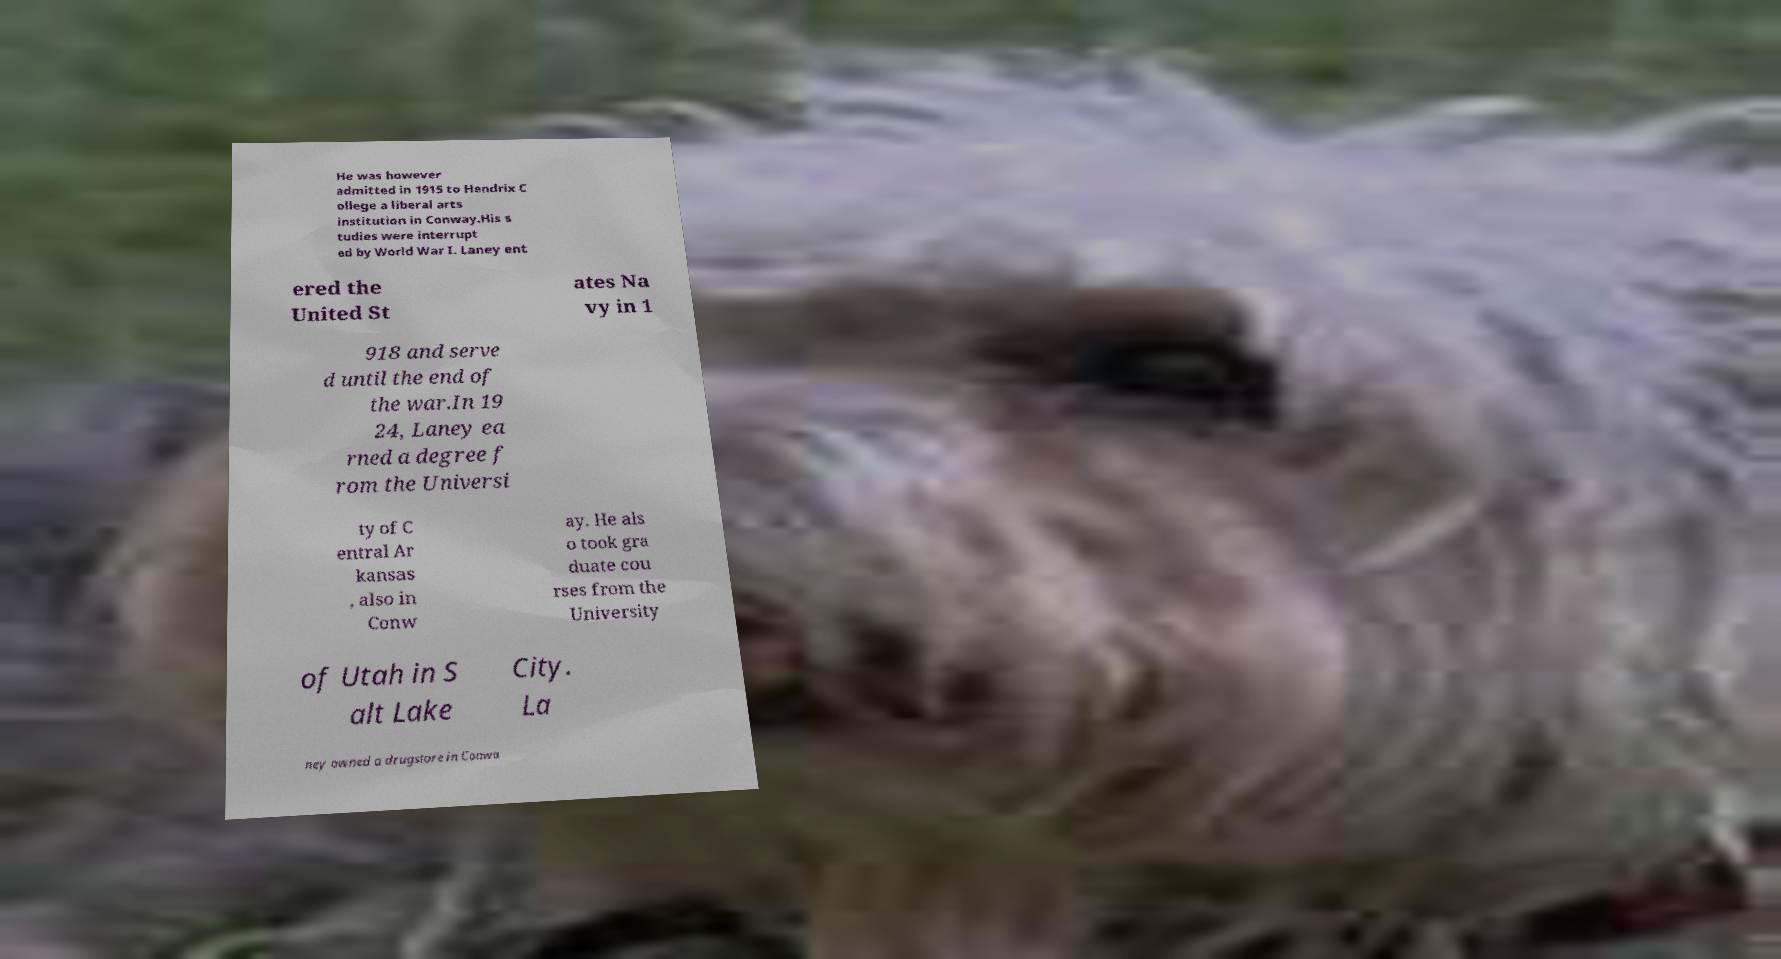For documentation purposes, I need the text within this image transcribed. Could you provide that? He was however admitted in 1915 to Hendrix C ollege a liberal arts institution in Conway.His s tudies were interrupt ed by World War I. Laney ent ered the United St ates Na vy in 1 918 and serve d until the end of the war.In 19 24, Laney ea rned a degree f rom the Universi ty of C entral Ar kansas , also in Conw ay. He als o took gra duate cou rses from the University of Utah in S alt Lake City. La ney owned a drugstore in Conwa 